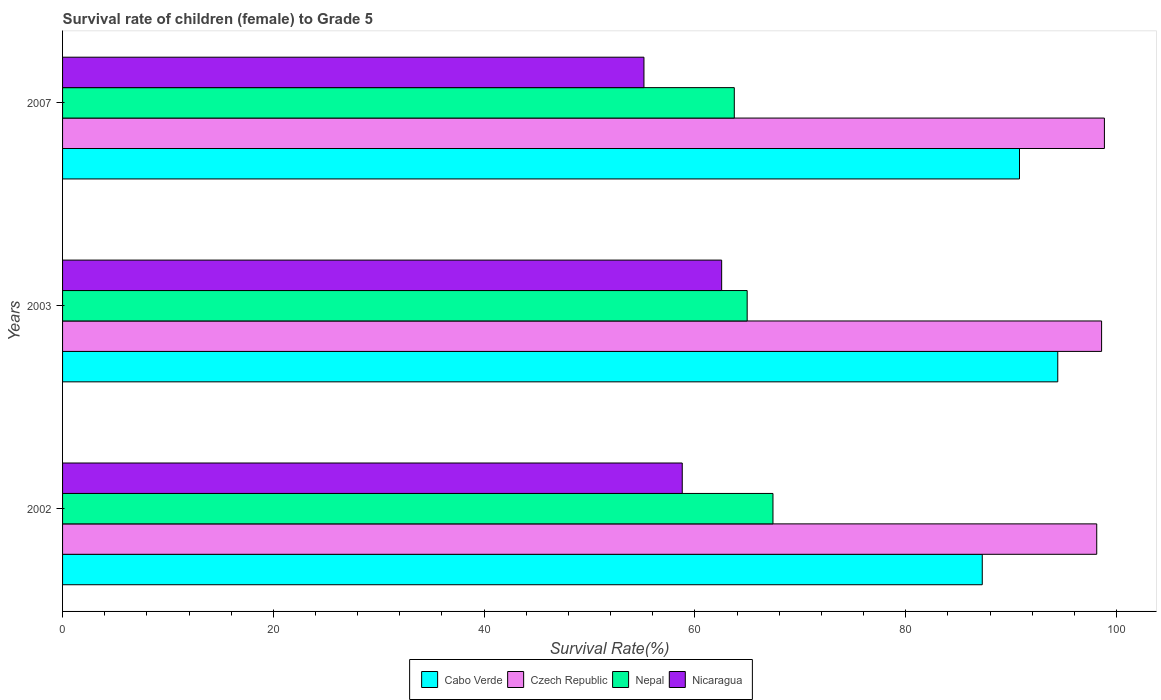How many different coloured bars are there?
Keep it short and to the point. 4. How many groups of bars are there?
Provide a succinct answer. 3. How many bars are there on the 1st tick from the top?
Make the answer very short. 4. What is the label of the 1st group of bars from the top?
Keep it short and to the point. 2007. What is the survival rate of female children to grade 5 in Nepal in 2007?
Your answer should be compact. 63.74. Across all years, what is the maximum survival rate of female children to grade 5 in Nepal?
Your response must be concise. 67.41. Across all years, what is the minimum survival rate of female children to grade 5 in Nepal?
Provide a succinct answer. 63.74. What is the total survival rate of female children to grade 5 in Nicaragua in the graph?
Provide a short and direct response. 176.5. What is the difference between the survival rate of female children to grade 5 in Nicaragua in 2002 and that in 2007?
Provide a short and direct response. 3.63. What is the difference between the survival rate of female children to grade 5 in Cabo Verde in 2003 and the survival rate of female children to grade 5 in Nicaragua in 2002?
Ensure brevity in your answer.  35.63. What is the average survival rate of female children to grade 5 in Nicaragua per year?
Your response must be concise. 58.83. In the year 2003, what is the difference between the survival rate of female children to grade 5 in Nicaragua and survival rate of female children to grade 5 in Czech Republic?
Make the answer very short. -36.05. In how many years, is the survival rate of female children to grade 5 in Nepal greater than 80 %?
Ensure brevity in your answer.  0. What is the ratio of the survival rate of female children to grade 5 in Cabo Verde in 2002 to that in 2003?
Give a very brief answer. 0.92. Is the survival rate of female children to grade 5 in Cabo Verde in 2003 less than that in 2007?
Ensure brevity in your answer.  No. What is the difference between the highest and the second highest survival rate of female children to grade 5 in Cabo Verde?
Your answer should be very brief. 3.63. What is the difference between the highest and the lowest survival rate of female children to grade 5 in Nepal?
Keep it short and to the point. 3.67. In how many years, is the survival rate of female children to grade 5 in Nepal greater than the average survival rate of female children to grade 5 in Nepal taken over all years?
Ensure brevity in your answer.  1. Is it the case that in every year, the sum of the survival rate of female children to grade 5 in Nepal and survival rate of female children to grade 5 in Czech Republic is greater than the sum of survival rate of female children to grade 5 in Nicaragua and survival rate of female children to grade 5 in Cabo Verde?
Provide a short and direct response. No. What does the 4th bar from the top in 2003 represents?
Offer a terse response. Cabo Verde. What does the 2nd bar from the bottom in 2007 represents?
Your response must be concise. Czech Republic. Is it the case that in every year, the sum of the survival rate of female children to grade 5 in Czech Republic and survival rate of female children to grade 5 in Cabo Verde is greater than the survival rate of female children to grade 5 in Nepal?
Offer a terse response. Yes. How many bars are there?
Your response must be concise. 12. How many years are there in the graph?
Your answer should be very brief. 3. What is the difference between two consecutive major ticks on the X-axis?
Ensure brevity in your answer.  20. Are the values on the major ticks of X-axis written in scientific E-notation?
Offer a very short reply. No. Does the graph contain grids?
Ensure brevity in your answer.  No. Where does the legend appear in the graph?
Ensure brevity in your answer.  Bottom center. How are the legend labels stacked?
Your answer should be compact. Horizontal. What is the title of the graph?
Give a very brief answer. Survival rate of children (female) to Grade 5. Does "Cote d'Ivoire" appear as one of the legend labels in the graph?
Ensure brevity in your answer.  No. What is the label or title of the X-axis?
Your response must be concise. Survival Rate(%). What is the label or title of the Y-axis?
Your answer should be compact. Years. What is the Survival Rate(%) of Cabo Verde in 2002?
Your answer should be compact. 87.27. What is the Survival Rate(%) in Czech Republic in 2002?
Your response must be concise. 98.13. What is the Survival Rate(%) in Nepal in 2002?
Your response must be concise. 67.41. What is the Survival Rate(%) of Nicaragua in 2002?
Your answer should be compact. 58.8. What is the Survival Rate(%) of Cabo Verde in 2003?
Ensure brevity in your answer.  94.43. What is the Survival Rate(%) of Czech Republic in 2003?
Keep it short and to the point. 98.59. What is the Survival Rate(%) in Nepal in 2003?
Your answer should be compact. 64.96. What is the Survival Rate(%) of Nicaragua in 2003?
Your response must be concise. 62.54. What is the Survival Rate(%) of Cabo Verde in 2007?
Offer a terse response. 90.8. What is the Survival Rate(%) of Czech Republic in 2007?
Offer a very short reply. 98.85. What is the Survival Rate(%) in Nepal in 2007?
Give a very brief answer. 63.74. What is the Survival Rate(%) of Nicaragua in 2007?
Offer a terse response. 55.16. Across all years, what is the maximum Survival Rate(%) in Cabo Verde?
Give a very brief answer. 94.43. Across all years, what is the maximum Survival Rate(%) of Czech Republic?
Your response must be concise. 98.85. Across all years, what is the maximum Survival Rate(%) of Nepal?
Offer a very short reply. 67.41. Across all years, what is the maximum Survival Rate(%) of Nicaragua?
Ensure brevity in your answer.  62.54. Across all years, what is the minimum Survival Rate(%) of Cabo Verde?
Provide a succinct answer. 87.27. Across all years, what is the minimum Survival Rate(%) in Czech Republic?
Your answer should be compact. 98.13. Across all years, what is the minimum Survival Rate(%) of Nepal?
Your answer should be very brief. 63.74. Across all years, what is the minimum Survival Rate(%) in Nicaragua?
Offer a terse response. 55.16. What is the total Survival Rate(%) of Cabo Verde in the graph?
Give a very brief answer. 272.49. What is the total Survival Rate(%) in Czech Republic in the graph?
Your answer should be compact. 295.57. What is the total Survival Rate(%) of Nepal in the graph?
Offer a terse response. 196.1. What is the total Survival Rate(%) in Nicaragua in the graph?
Your answer should be compact. 176.5. What is the difference between the Survival Rate(%) in Cabo Verde in 2002 and that in 2003?
Your answer should be compact. -7.16. What is the difference between the Survival Rate(%) of Czech Republic in 2002 and that in 2003?
Offer a terse response. -0.46. What is the difference between the Survival Rate(%) of Nepal in 2002 and that in 2003?
Your answer should be very brief. 2.45. What is the difference between the Survival Rate(%) of Nicaragua in 2002 and that in 2003?
Your answer should be compact. -3.74. What is the difference between the Survival Rate(%) of Cabo Verde in 2002 and that in 2007?
Your answer should be compact. -3.53. What is the difference between the Survival Rate(%) in Czech Republic in 2002 and that in 2007?
Give a very brief answer. -0.73. What is the difference between the Survival Rate(%) in Nepal in 2002 and that in 2007?
Provide a short and direct response. 3.67. What is the difference between the Survival Rate(%) of Nicaragua in 2002 and that in 2007?
Give a very brief answer. 3.63. What is the difference between the Survival Rate(%) in Cabo Verde in 2003 and that in 2007?
Make the answer very short. 3.63. What is the difference between the Survival Rate(%) in Czech Republic in 2003 and that in 2007?
Offer a very short reply. -0.27. What is the difference between the Survival Rate(%) in Nepal in 2003 and that in 2007?
Ensure brevity in your answer.  1.22. What is the difference between the Survival Rate(%) of Nicaragua in 2003 and that in 2007?
Keep it short and to the point. 7.37. What is the difference between the Survival Rate(%) of Cabo Verde in 2002 and the Survival Rate(%) of Czech Republic in 2003?
Keep it short and to the point. -11.32. What is the difference between the Survival Rate(%) in Cabo Verde in 2002 and the Survival Rate(%) in Nepal in 2003?
Offer a terse response. 22.31. What is the difference between the Survival Rate(%) of Cabo Verde in 2002 and the Survival Rate(%) of Nicaragua in 2003?
Your response must be concise. 24.73. What is the difference between the Survival Rate(%) in Czech Republic in 2002 and the Survival Rate(%) in Nepal in 2003?
Ensure brevity in your answer.  33.17. What is the difference between the Survival Rate(%) of Czech Republic in 2002 and the Survival Rate(%) of Nicaragua in 2003?
Make the answer very short. 35.59. What is the difference between the Survival Rate(%) in Nepal in 2002 and the Survival Rate(%) in Nicaragua in 2003?
Your response must be concise. 4.87. What is the difference between the Survival Rate(%) of Cabo Verde in 2002 and the Survival Rate(%) of Czech Republic in 2007?
Your response must be concise. -11.59. What is the difference between the Survival Rate(%) in Cabo Verde in 2002 and the Survival Rate(%) in Nepal in 2007?
Give a very brief answer. 23.53. What is the difference between the Survival Rate(%) in Cabo Verde in 2002 and the Survival Rate(%) in Nicaragua in 2007?
Offer a terse response. 32.1. What is the difference between the Survival Rate(%) in Czech Republic in 2002 and the Survival Rate(%) in Nepal in 2007?
Provide a short and direct response. 34.39. What is the difference between the Survival Rate(%) of Czech Republic in 2002 and the Survival Rate(%) of Nicaragua in 2007?
Offer a very short reply. 42.96. What is the difference between the Survival Rate(%) of Nepal in 2002 and the Survival Rate(%) of Nicaragua in 2007?
Your response must be concise. 12.24. What is the difference between the Survival Rate(%) in Cabo Verde in 2003 and the Survival Rate(%) in Czech Republic in 2007?
Ensure brevity in your answer.  -4.42. What is the difference between the Survival Rate(%) of Cabo Verde in 2003 and the Survival Rate(%) of Nepal in 2007?
Ensure brevity in your answer.  30.69. What is the difference between the Survival Rate(%) of Cabo Verde in 2003 and the Survival Rate(%) of Nicaragua in 2007?
Your response must be concise. 39.27. What is the difference between the Survival Rate(%) of Czech Republic in 2003 and the Survival Rate(%) of Nepal in 2007?
Your answer should be compact. 34.85. What is the difference between the Survival Rate(%) in Czech Republic in 2003 and the Survival Rate(%) in Nicaragua in 2007?
Offer a terse response. 43.42. What is the difference between the Survival Rate(%) of Nepal in 2003 and the Survival Rate(%) of Nicaragua in 2007?
Keep it short and to the point. 9.79. What is the average Survival Rate(%) in Cabo Verde per year?
Offer a terse response. 90.83. What is the average Survival Rate(%) in Czech Republic per year?
Offer a very short reply. 98.52. What is the average Survival Rate(%) of Nepal per year?
Keep it short and to the point. 65.37. What is the average Survival Rate(%) in Nicaragua per year?
Keep it short and to the point. 58.83. In the year 2002, what is the difference between the Survival Rate(%) in Cabo Verde and Survival Rate(%) in Czech Republic?
Provide a short and direct response. -10.86. In the year 2002, what is the difference between the Survival Rate(%) in Cabo Verde and Survival Rate(%) in Nepal?
Offer a very short reply. 19.86. In the year 2002, what is the difference between the Survival Rate(%) of Cabo Verde and Survival Rate(%) of Nicaragua?
Ensure brevity in your answer.  28.47. In the year 2002, what is the difference between the Survival Rate(%) of Czech Republic and Survival Rate(%) of Nepal?
Provide a short and direct response. 30.72. In the year 2002, what is the difference between the Survival Rate(%) in Czech Republic and Survival Rate(%) in Nicaragua?
Provide a short and direct response. 39.33. In the year 2002, what is the difference between the Survival Rate(%) of Nepal and Survival Rate(%) of Nicaragua?
Your response must be concise. 8.61. In the year 2003, what is the difference between the Survival Rate(%) of Cabo Verde and Survival Rate(%) of Czech Republic?
Give a very brief answer. -4.16. In the year 2003, what is the difference between the Survival Rate(%) in Cabo Verde and Survival Rate(%) in Nepal?
Your answer should be very brief. 29.47. In the year 2003, what is the difference between the Survival Rate(%) of Cabo Verde and Survival Rate(%) of Nicaragua?
Your answer should be very brief. 31.89. In the year 2003, what is the difference between the Survival Rate(%) of Czech Republic and Survival Rate(%) of Nepal?
Your answer should be compact. 33.63. In the year 2003, what is the difference between the Survival Rate(%) in Czech Republic and Survival Rate(%) in Nicaragua?
Keep it short and to the point. 36.05. In the year 2003, what is the difference between the Survival Rate(%) of Nepal and Survival Rate(%) of Nicaragua?
Give a very brief answer. 2.42. In the year 2007, what is the difference between the Survival Rate(%) of Cabo Verde and Survival Rate(%) of Czech Republic?
Offer a terse response. -8.06. In the year 2007, what is the difference between the Survival Rate(%) in Cabo Verde and Survival Rate(%) in Nepal?
Your answer should be compact. 27.06. In the year 2007, what is the difference between the Survival Rate(%) of Cabo Verde and Survival Rate(%) of Nicaragua?
Make the answer very short. 35.63. In the year 2007, what is the difference between the Survival Rate(%) in Czech Republic and Survival Rate(%) in Nepal?
Provide a succinct answer. 35.12. In the year 2007, what is the difference between the Survival Rate(%) of Czech Republic and Survival Rate(%) of Nicaragua?
Offer a terse response. 43.69. In the year 2007, what is the difference between the Survival Rate(%) of Nepal and Survival Rate(%) of Nicaragua?
Give a very brief answer. 8.57. What is the ratio of the Survival Rate(%) in Cabo Verde in 2002 to that in 2003?
Ensure brevity in your answer.  0.92. What is the ratio of the Survival Rate(%) in Nepal in 2002 to that in 2003?
Provide a short and direct response. 1.04. What is the ratio of the Survival Rate(%) of Nicaragua in 2002 to that in 2003?
Offer a terse response. 0.94. What is the ratio of the Survival Rate(%) in Cabo Verde in 2002 to that in 2007?
Keep it short and to the point. 0.96. What is the ratio of the Survival Rate(%) of Nepal in 2002 to that in 2007?
Give a very brief answer. 1.06. What is the ratio of the Survival Rate(%) of Nicaragua in 2002 to that in 2007?
Give a very brief answer. 1.07. What is the ratio of the Survival Rate(%) in Czech Republic in 2003 to that in 2007?
Provide a short and direct response. 1. What is the ratio of the Survival Rate(%) in Nepal in 2003 to that in 2007?
Give a very brief answer. 1.02. What is the ratio of the Survival Rate(%) in Nicaragua in 2003 to that in 2007?
Your answer should be very brief. 1.13. What is the difference between the highest and the second highest Survival Rate(%) in Cabo Verde?
Give a very brief answer. 3.63. What is the difference between the highest and the second highest Survival Rate(%) in Czech Republic?
Provide a short and direct response. 0.27. What is the difference between the highest and the second highest Survival Rate(%) in Nepal?
Ensure brevity in your answer.  2.45. What is the difference between the highest and the second highest Survival Rate(%) of Nicaragua?
Give a very brief answer. 3.74. What is the difference between the highest and the lowest Survival Rate(%) of Cabo Verde?
Keep it short and to the point. 7.16. What is the difference between the highest and the lowest Survival Rate(%) in Czech Republic?
Provide a short and direct response. 0.73. What is the difference between the highest and the lowest Survival Rate(%) of Nepal?
Give a very brief answer. 3.67. What is the difference between the highest and the lowest Survival Rate(%) in Nicaragua?
Your answer should be very brief. 7.37. 